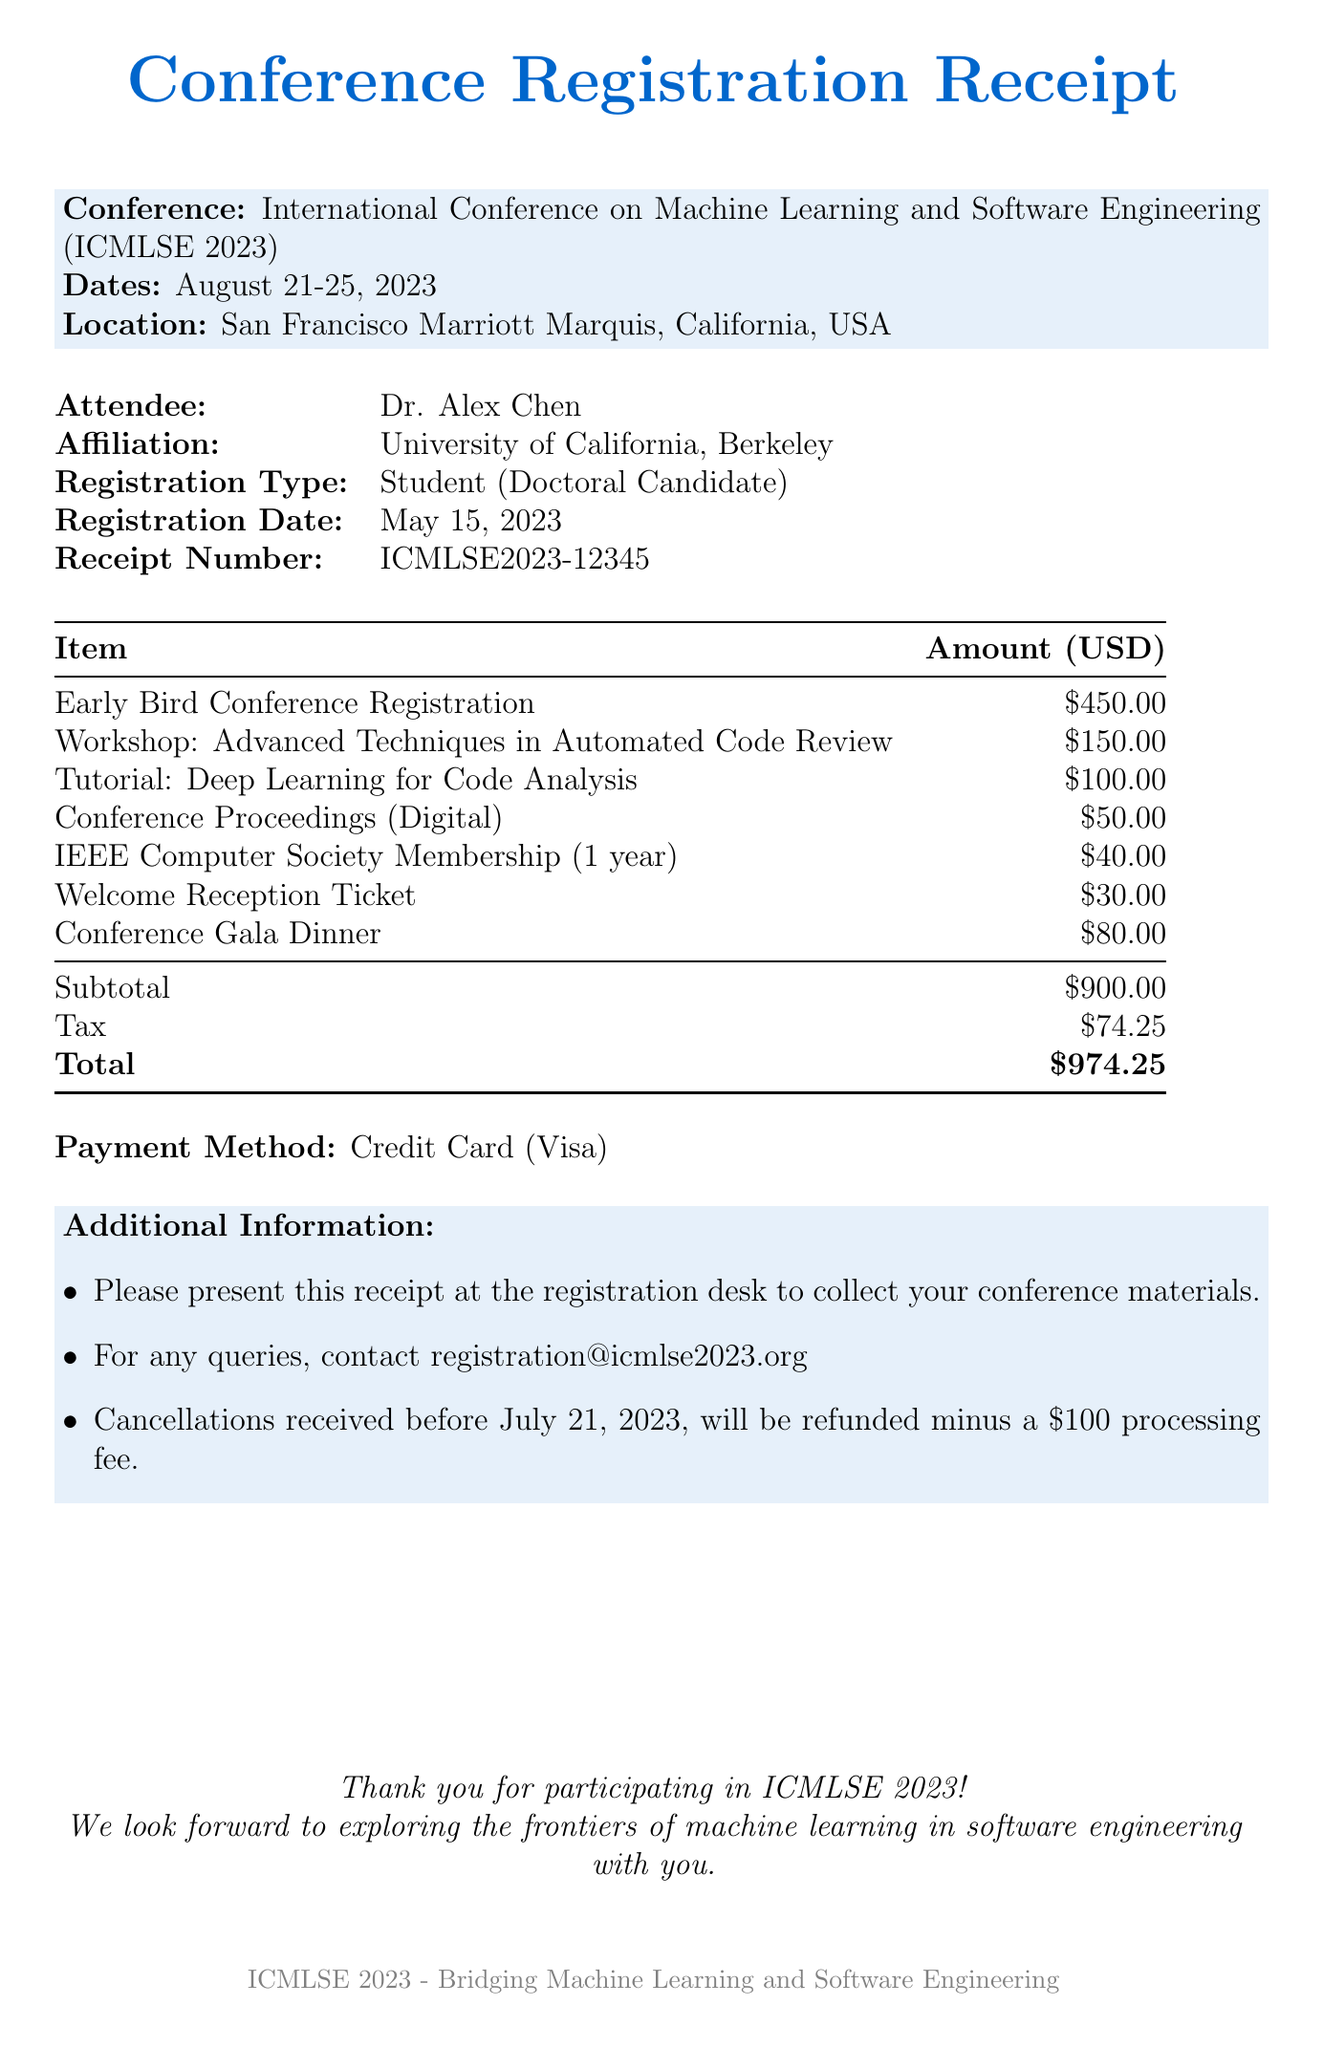What is the name of the conference? The name of the conference is stated in the document, which is "International Conference on Machine Learning and Software Engineering (ICMLSE 2023)."
Answer: International Conference on Machine Learning and Software Engineering (ICMLSE 2023) What is the attendee's affiliation? The document specifies that the attendee is affiliated with "University of California, Berkeley."
Answer: University of California, Berkeley What is the registration date? The registration date can be found in the document and is noted as "May 15, 2023."
Answer: May 15, 2023 What is the amount for the "Conference Gala Dinner"? The amount for this item is detailed in the itemized list, which states "$80.00."
Answer: $80.00 What is the total cost of the registration? The total cost is provided as the final amount at the end of the document, which is "$974.25."
Answer: $974.25 How many items are listed in the receipt? The receipt details multiple items, and by counting them in the itemized list, it is clear that there are "7" items listed.
Answer: 7 What is the payment method used for the registration? The payment method is explicitly mentioned in the document, which states "Credit Card (Visa)."
Answer: Credit Card (Visa) What happens if a cancellation is received after July 21, 2023? The cancellation policy implies that after a specified date, a processing fee applies, so the answer is "no refund."
Answer: no refund What is the location of the conference? The location is included in the details of the conference, noted as "San Francisco Marriott Marquis, California, USA."
Answer: San Francisco Marriott Marquis, California, USA 